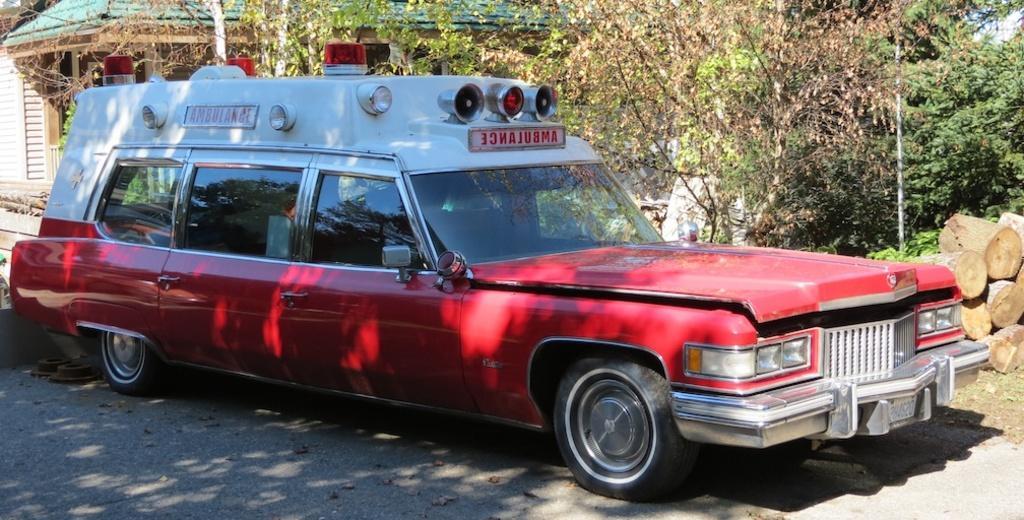Please provide a concise description of this image. In this picture we can see a car on the road. In the background we can see a house, trees, wooden logs and a pole. 